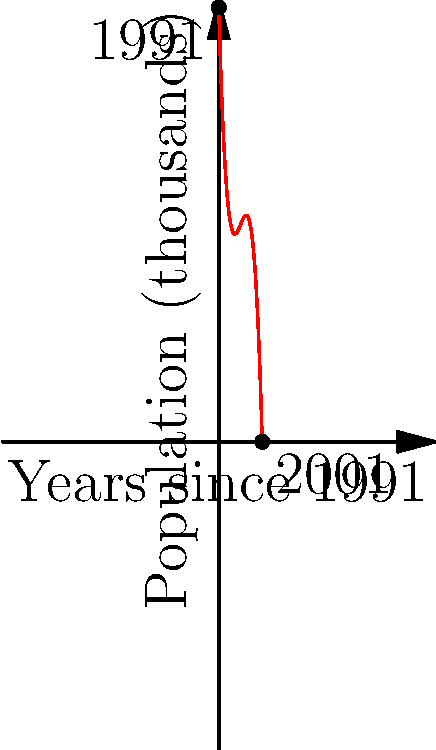The graph shows the population decline in a former Soviet mining town from 1991 to 2001, modeled by a third-degree polynomial function. If this trend continues, in which year after 1991 will the town's population reach zero? To solve this problem, we need to follow these steps:

1. Observe that the polynomial function intersects the x-axis when the population reaches zero.

2. The function appears to be of the form:
   $$f(x) = -0.5x^3 + 7.5x^2 - 35x + 100$$
   where $x$ is the number of years since 1991 and $f(x)$ is the population in thousands.

3. To find when the population reaches zero, we need to solve:
   $$-0.5x^3 + 7.5x^2 - 35x + 100 = 0$$

4. This equation is difficult to solve analytically, so we can use a graphical or numerical method.

5. By extending the graph or using a calculator, we can estimate that the function reaches zero around $x = 13.5$.

6. This means the population will reach zero approximately 13.5 years after 1991.

7. Adding 13.5 to 1991 gives us 2004.5, which rounds to 2005.

Therefore, if the trend continues, the town's population will reach zero around the year 2005, which is 14 years after 1991.
Answer: 14 years 